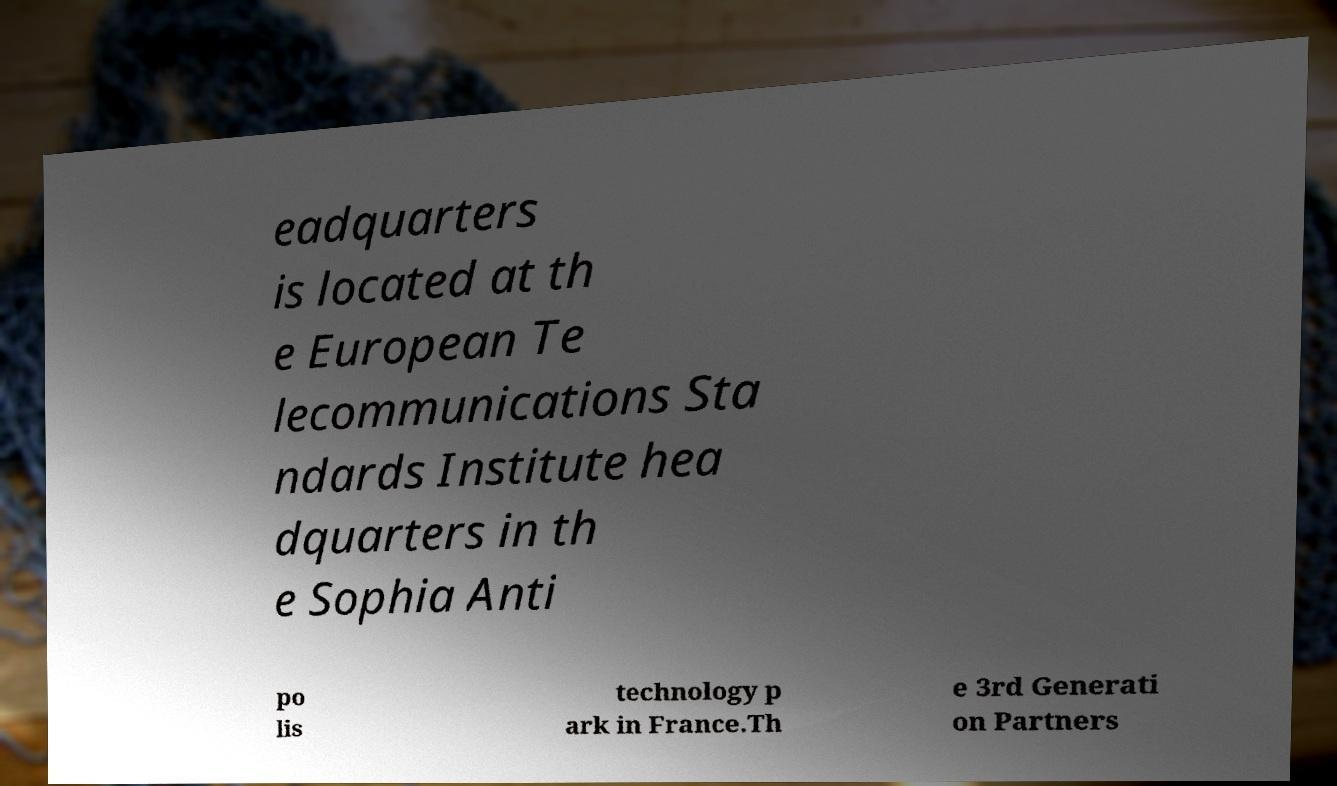Can you read and provide the text displayed in the image?This photo seems to have some interesting text. Can you extract and type it out for me? eadquarters is located at th e European Te lecommunications Sta ndards Institute hea dquarters in th e Sophia Anti po lis technology p ark in France.Th e 3rd Generati on Partners 